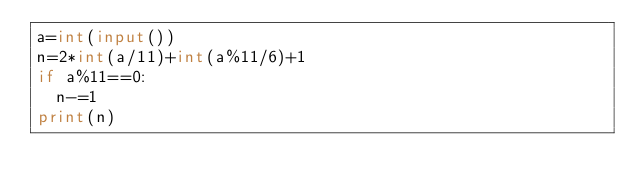Convert code to text. <code><loc_0><loc_0><loc_500><loc_500><_Python_>a=int(input())
n=2*int(a/11)+int(a%11/6)+1
if a%11==0:
  n-=1
print(n)</code> 